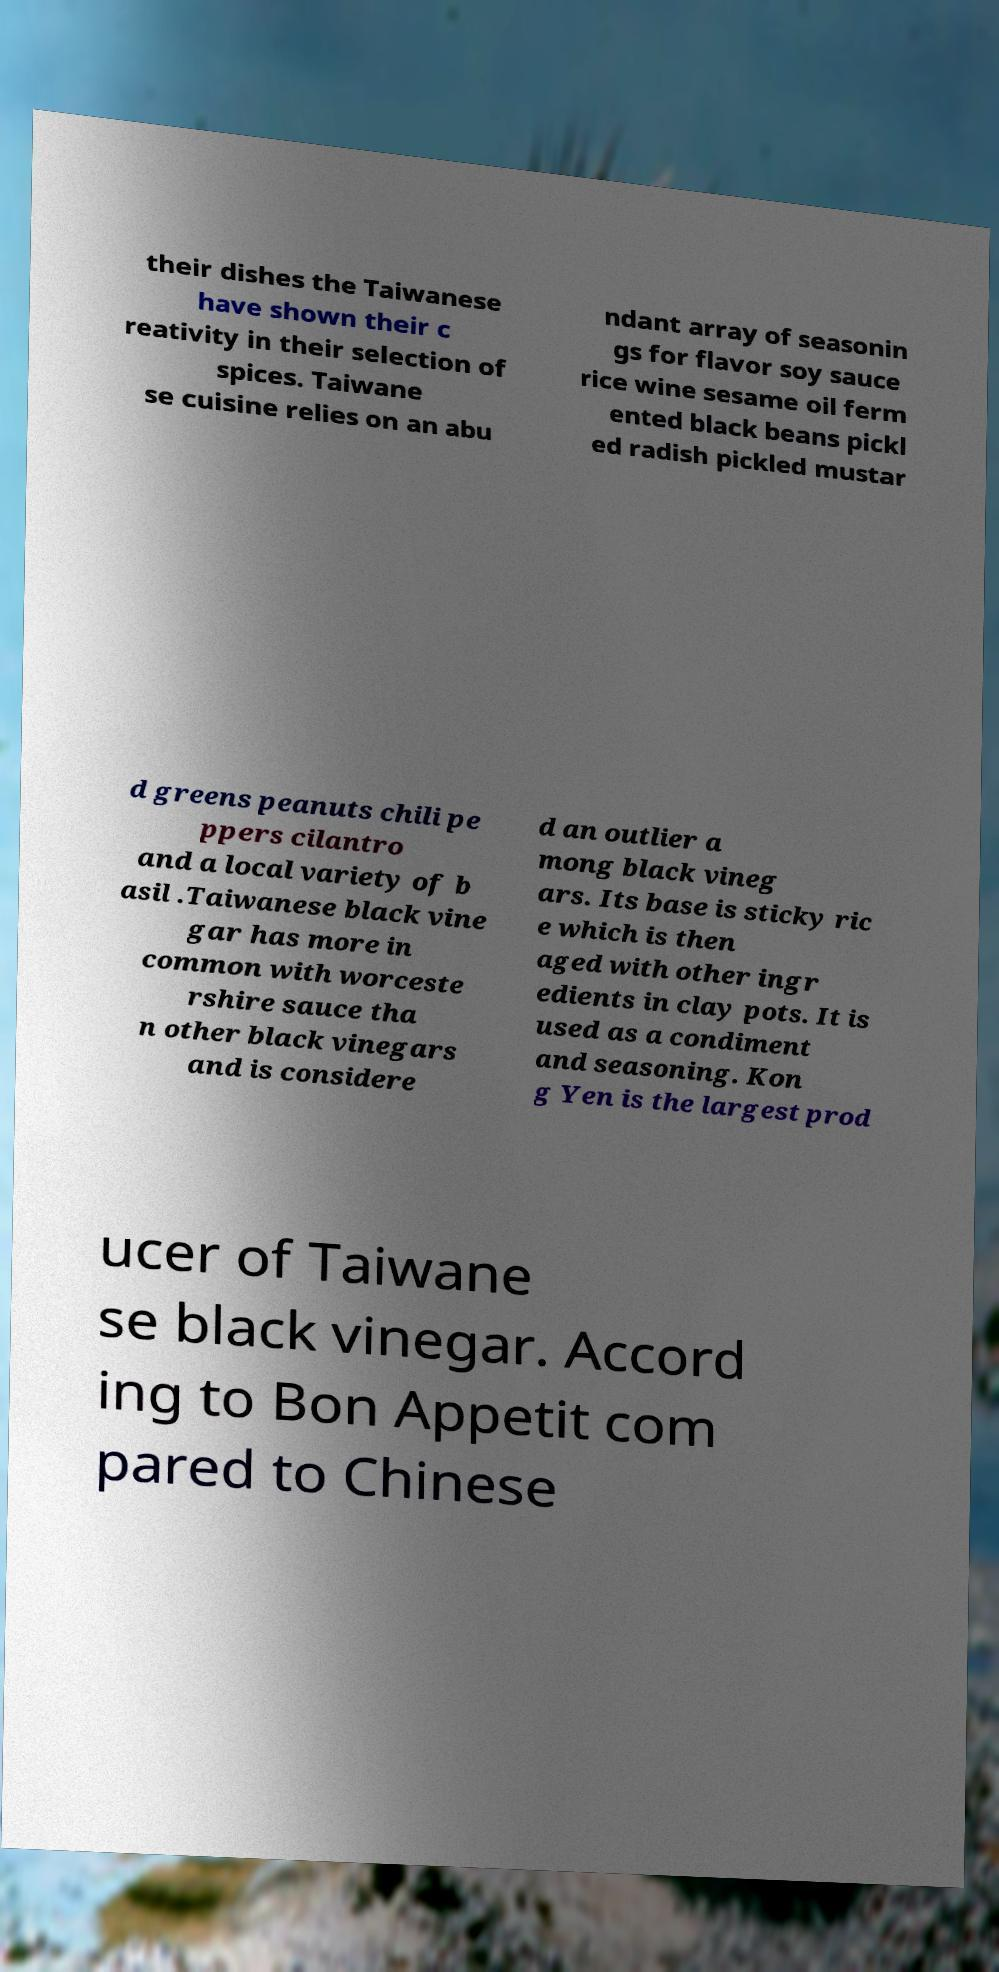Can you accurately transcribe the text from the provided image for me? their dishes the Taiwanese have shown their c reativity in their selection of spices. Taiwane se cuisine relies on an abu ndant array of seasonin gs for flavor soy sauce rice wine sesame oil ferm ented black beans pickl ed radish pickled mustar d greens peanuts chili pe ppers cilantro and a local variety of b asil .Taiwanese black vine gar has more in common with worceste rshire sauce tha n other black vinegars and is considere d an outlier a mong black vineg ars. Its base is sticky ric e which is then aged with other ingr edients in clay pots. It is used as a condiment and seasoning. Kon g Yen is the largest prod ucer of Taiwane se black vinegar. Accord ing to Bon Appetit com pared to Chinese 